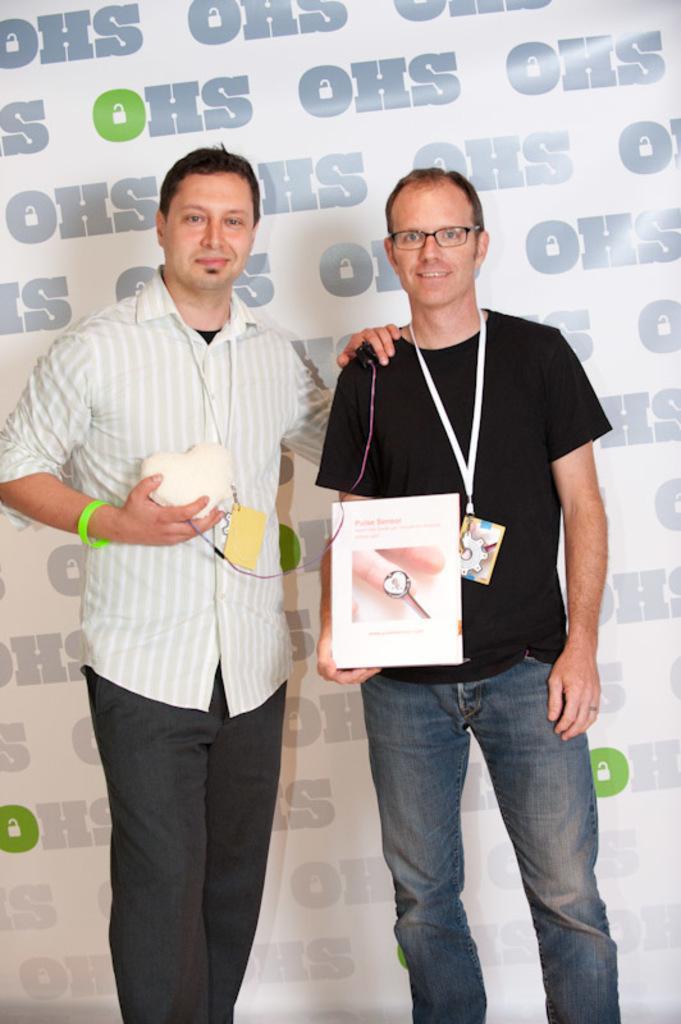Can you describe this image briefly? In the image we can see two men standing, wearing clothes, identity card and they are smiling. They are holding an object in their hand and the left side man is wearing spectacles, this is a poster. 